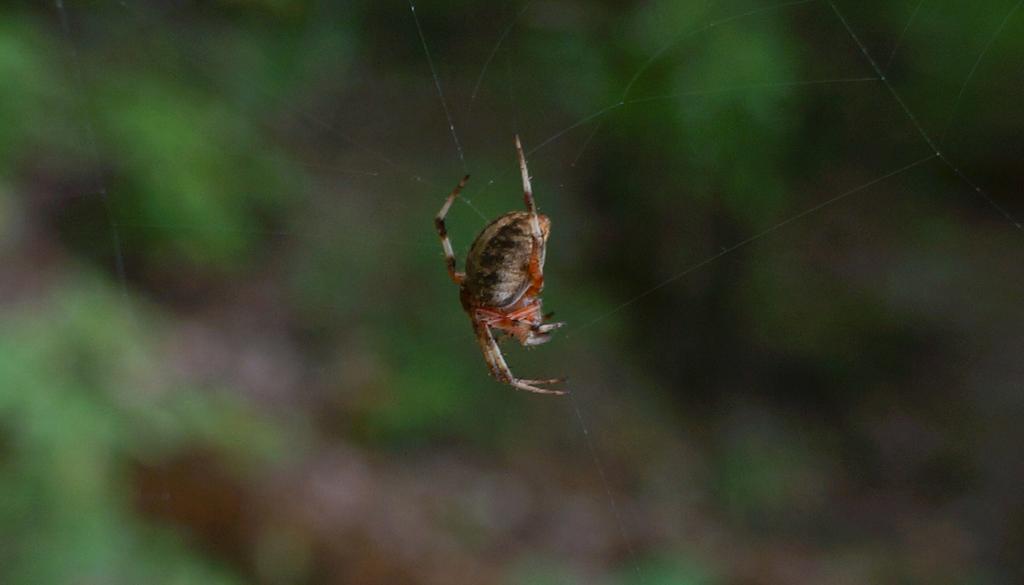How would you summarize this image in a sentence or two? In this image we can see a spider and a web, and the background is blurred. 